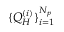<formula> <loc_0><loc_0><loc_500><loc_500>\{ Q _ { H } ^ { ( i ) } \} _ { i = 1 } ^ { N _ { p } }</formula> 